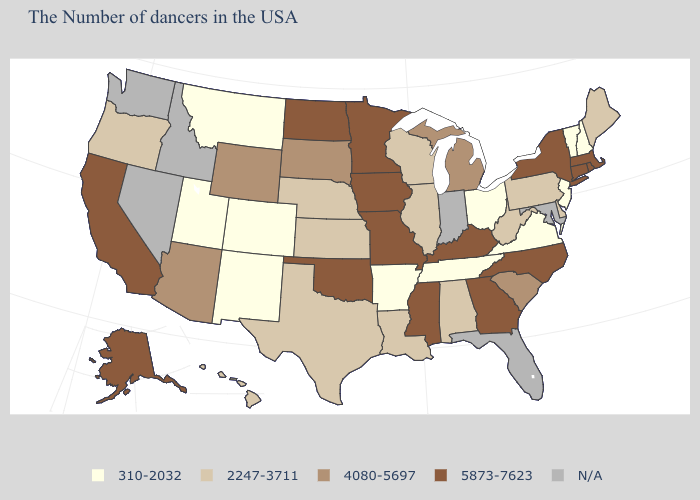Which states hav the highest value in the West?
Short answer required. California, Alaska. Name the states that have a value in the range 2247-3711?
Concise answer only. Maine, Delaware, Pennsylvania, West Virginia, Alabama, Wisconsin, Illinois, Louisiana, Kansas, Nebraska, Texas, Oregon, Hawaii. Which states have the highest value in the USA?
Keep it brief. Massachusetts, Rhode Island, Connecticut, New York, North Carolina, Georgia, Kentucky, Mississippi, Missouri, Minnesota, Iowa, Oklahoma, North Dakota, California, Alaska. Name the states that have a value in the range 2247-3711?
Quick response, please. Maine, Delaware, Pennsylvania, West Virginia, Alabama, Wisconsin, Illinois, Louisiana, Kansas, Nebraska, Texas, Oregon, Hawaii. Name the states that have a value in the range 5873-7623?
Keep it brief. Massachusetts, Rhode Island, Connecticut, New York, North Carolina, Georgia, Kentucky, Mississippi, Missouri, Minnesota, Iowa, Oklahoma, North Dakota, California, Alaska. What is the value of Georgia?
Answer briefly. 5873-7623. Name the states that have a value in the range 4080-5697?
Quick response, please. South Carolina, Michigan, South Dakota, Wyoming, Arizona. What is the lowest value in the USA?
Answer briefly. 310-2032. What is the lowest value in states that border Florida?
Give a very brief answer. 2247-3711. What is the value of California?
Answer briefly. 5873-7623. Which states have the lowest value in the South?
Keep it brief. Virginia, Tennessee, Arkansas. Name the states that have a value in the range 2247-3711?
Give a very brief answer. Maine, Delaware, Pennsylvania, West Virginia, Alabama, Wisconsin, Illinois, Louisiana, Kansas, Nebraska, Texas, Oregon, Hawaii. What is the value of Arkansas?
Short answer required. 310-2032. Among the states that border Iowa , which have the highest value?
Short answer required. Missouri, Minnesota. Name the states that have a value in the range 4080-5697?
Quick response, please. South Carolina, Michigan, South Dakota, Wyoming, Arizona. 